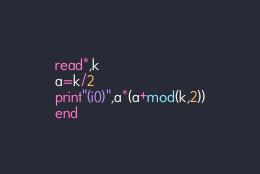Convert code to text. <code><loc_0><loc_0><loc_500><loc_500><_FORTRAN_>read*,k
a=k/2
print"(i0)",a*(a+mod(k,2))
end</code> 